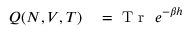Convert formula to latex. <formula><loc_0><loc_0><loc_500><loc_500>\begin{array} { r l } { Q ( N , V , T ) } & = T r e ^ { - \beta h } } \end{array}</formula> 